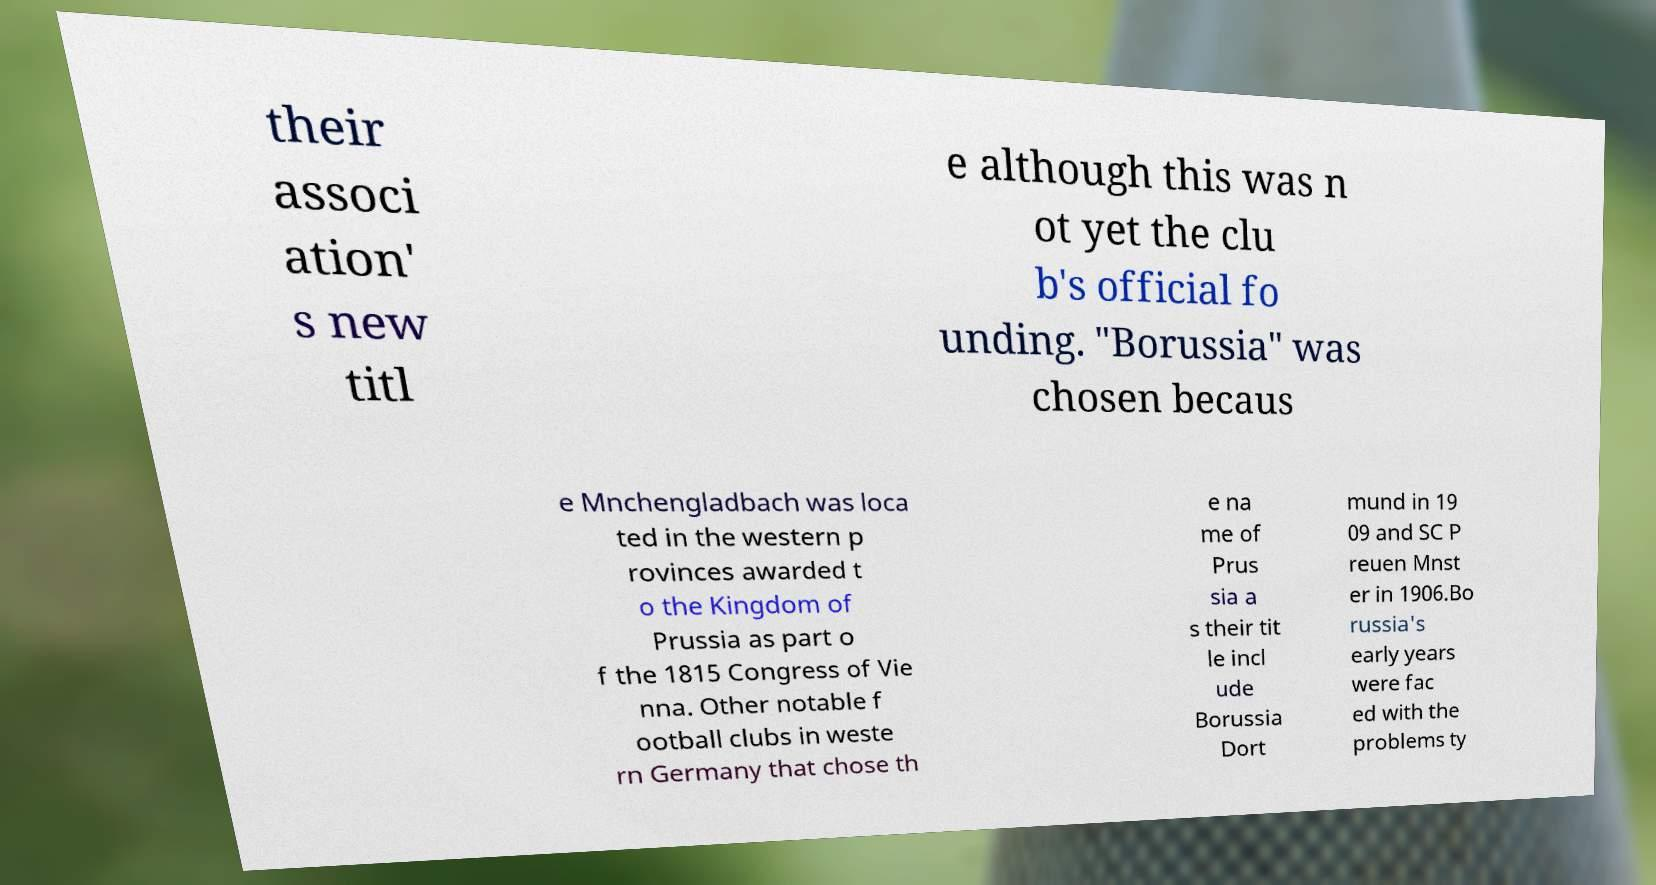For documentation purposes, I need the text within this image transcribed. Could you provide that? their associ ation' s new titl e although this was n ot yet the clu b's official fo unding. "Borussia" was chosen becaus e Mnchengladbach was loca ted in the western p rovinces awarded t o the Kingdom of Prussia as part o f the 1815 Congress of Vie nna. Other notable f ootball clubs in weste rn Germany that chose th e na me of Prus sia a s their tit le incl ude Borussia Dort mund in 19 09 and SC P reuen Mnst er in 1906.Bo russia's early years were fac ed with the problems ty 